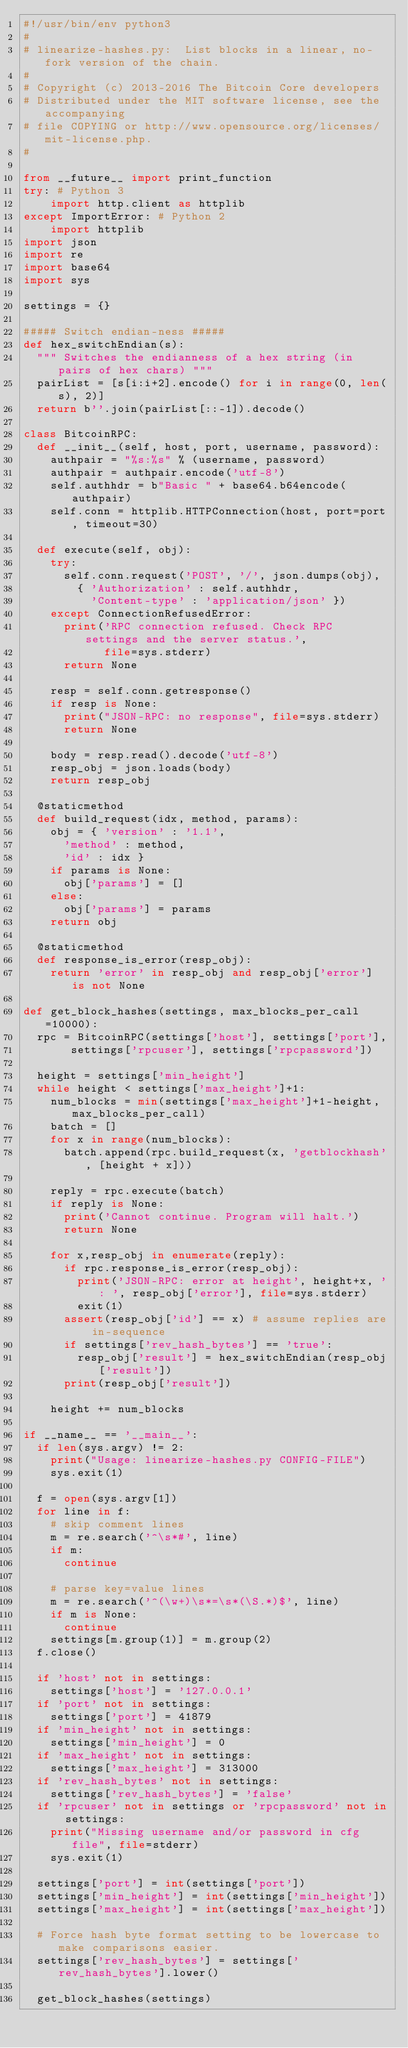<code> <loc_0><loc_0><loc_500><loc_500><_Python_>#!/usr/bin/env python3
#
# linearize-hashes.py:  List blocks in a linear, no-fork version of the chain.
#
# Copyright (c) 2013-2016 The Bitcoin Core developers
# Distributed under the MIT software license, see the accompanying
# file COPYING or http://www.opensource.org/licenses/mit-license.php.
#

from __future__ import print_function
try: # Python 3
    import http.client as httplib
except ImportError: # Python 2
    import httplib
import json
import re
import base64
import sys

settings = {}

##### Switch endian-ness #####
def hex_switchEndian(s):
	""" Switches the endianness of a hex string (in pairs of hex chars) """
	pairList = [s[i:i+2].encode() for i in range(0, len(s), 2)]
	return b''.join(pairList[::-1]).decode()

class BitcoinRPC:
	def __init__(self, host, port, username, password):
		authpair = "%s:%s" % (username, password)
		authpair = authpair.encode('utf-8')
		self.authhdr = b"Basic " + base64.b64encode(authpair)
		self.conn = httplib.HTTPConnection(host, port=port, timeout=30)

	def execute(self, obj):
		try:
			self.conn.request('POST', '/', json.dumps(obj),
				{ 'Authorization' : self.authhdr,
				  'Content-type' : 'application/json' })
		except ConnectionRefusedError:
			print('RPC connection refused. Check RPC settings and the server status.',
			      file=sys.stderr)
			return None

		resp = self.conn.getresponse()
		if resp is None:
			print("JSON-RPC: no response", file=sys.stderr)
			return None

		body = resp.read().decode('utf-8')
		resp_obj = json.loads(body)
		return resp_obj

	@staticmethod
	def build_request(idx, method, params):
		obj = { 'version' : '1.1',
			'method' : method,
			'id' : idx }
		if params is None:
			obj['params'] = []
		else:
			obj['params'] = params
		return obj

	@staticmethod
	def response_is_error(resp_obj):
		return 'error' in resp_obj and resp_obj['error'] is not None

def get_block_hashes(settings, max_blocks_per_call=10000):
	rpc = BitcoinRPC(settings['host'], settings['port'],
			 settings['rpcuser'], settings['rpcpassword'])

	height = settings['min_height']
	while height < settings['max_height']+1:
		num_blocks = min(settings['max_height']+1-height, max_blocks_per_call)
		batch = []
		for x in range(num_blocks):
			batch.append(rpc.build_request(x, 'getblockhash', [height + x]))

		reply = rpc.execute(batch)
		if reply is None:
			print('Cannot continue. Program will halt.')
			return None

		for x,resp_obj in enumerate(reply):
			if rpc.response_is_error(resp_obj):
				print('JSON-RPC: error at height', height+x, ': ', resp_obj['error'], file=sys.stderr)
				exit(1)
			assert(resp_obj['id'] == x) # assume replies are in-sequence
			if settings['rev_hash_bytes'] == 'true':
				resp_obj['result'] = hex_switchEndian(resp_obj['result'])
			print(resp_obj['result'])

		height += num_blocks

if __name__ == '__main__':
	if len(sys.argv) != 2:
		print("Usage: linearize-hashes.py CONFIG-FILE")
		sys.exit(1)

	f = open(sys.argv[1])
	for line in f:
		# skip comment lines
		m = re.search('^\s*#', line)
		if m:
			continue

		# parse key=value lines
		m = re.search('^(\w+)\s*=\s*(\S.*)$', line)
		if m is None:
			continue
		settings[m.group(1)] = m.group(2)
	f.close()

	if 'host' not in settings:
		settings['host'] = '127.0.0.1'
	if 'port' not in settings:
		settings['port'] = 41879
	if 'min_height' not in settings:
		settings['min_height'] = 0
	if 'max_height' not in settings:
		settings['max_height'] = 313000
	if 'rev_hash_bytes' not in settings:
		settings['rev_hash_bytes'] = 'false'
	if 'rpcuser' not in settings or 'rpcpassword' not in settings:
		print("Missing username and/or password in cfg file", file=stderr)
		sys.exit(1)

	settings['port'] = int(settings['port'])
	settings['min_height'] = int(settings['min_height'])
	settings['max_height'] = int(settings['max_height'])

	# Force hash byte format setting to be lowercase to make comparisons easier.
	settings['rev_hash_bytes'] = settings['rev_hash_bytes'].lower()

	get_block_hashes(settings)
</code> 